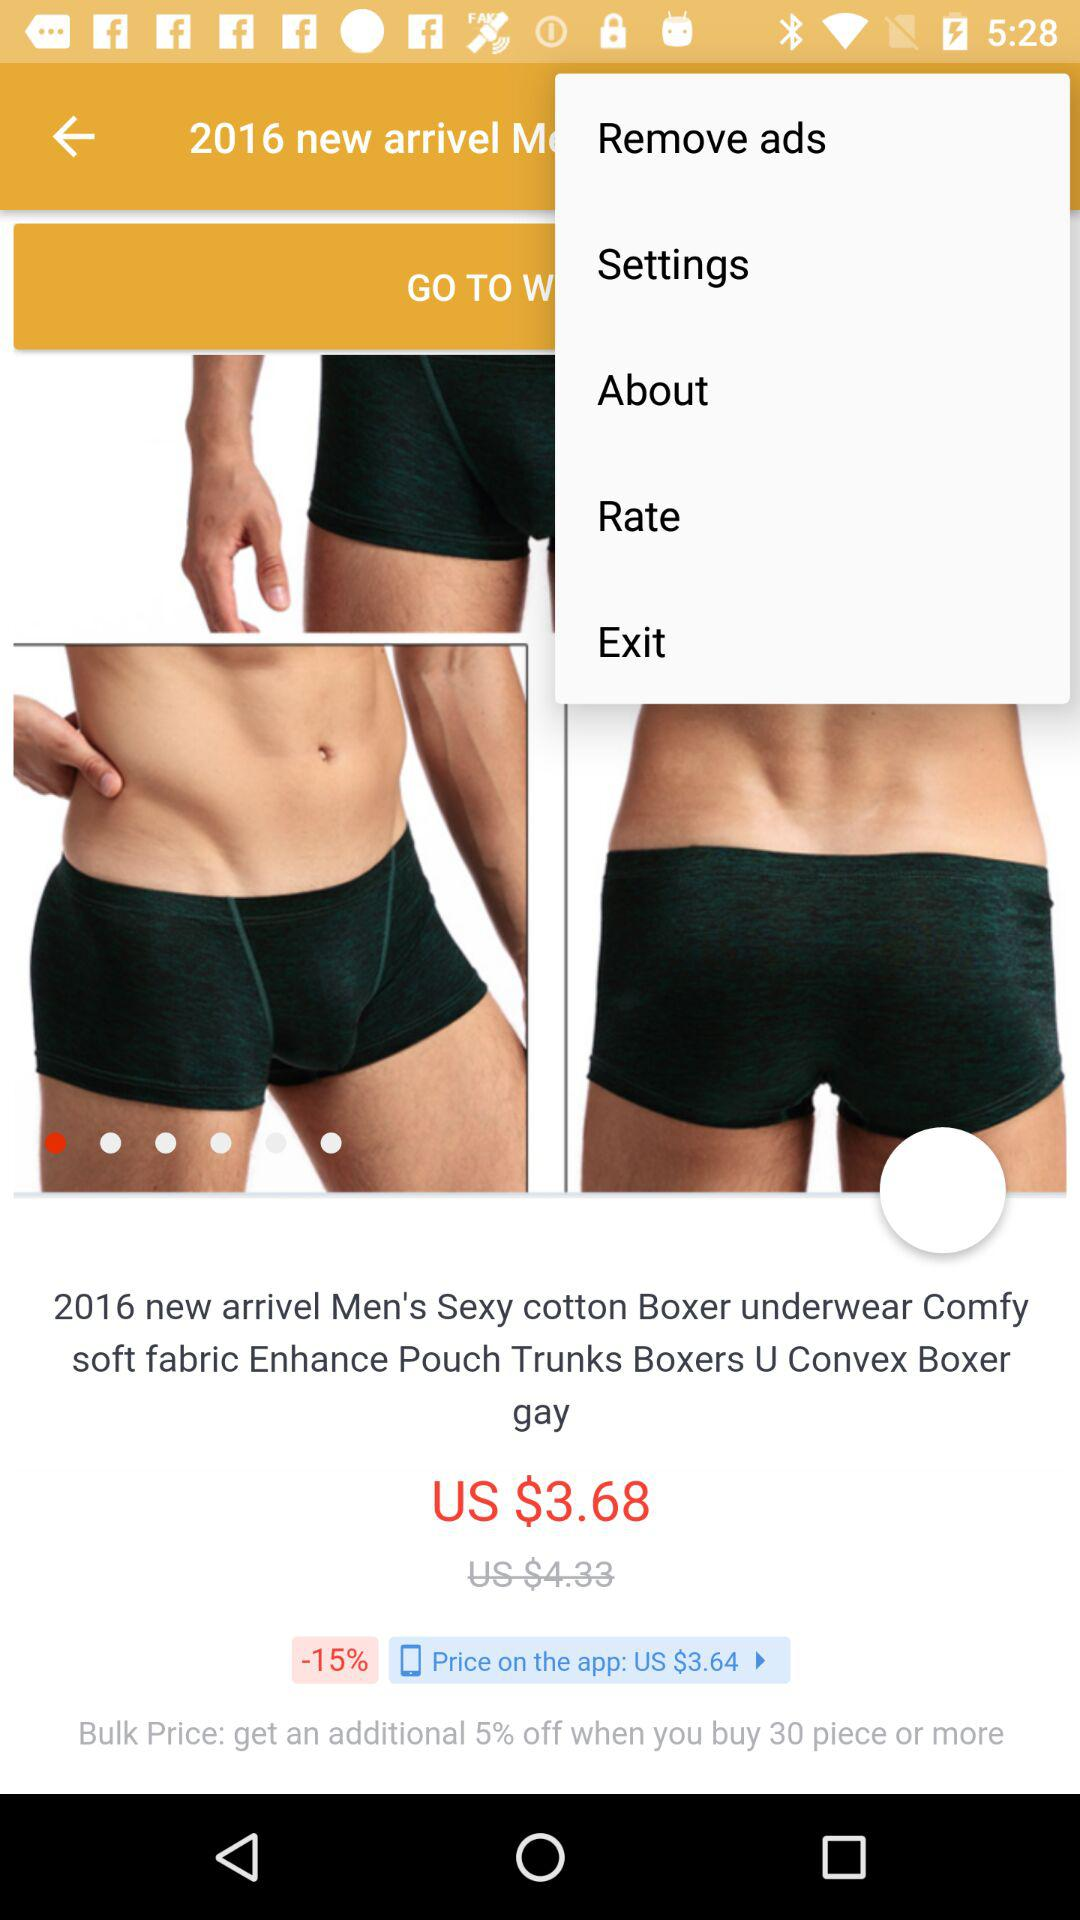What is the additional discount percentage for orders of 30 pieces? The additional discount is 5%. 